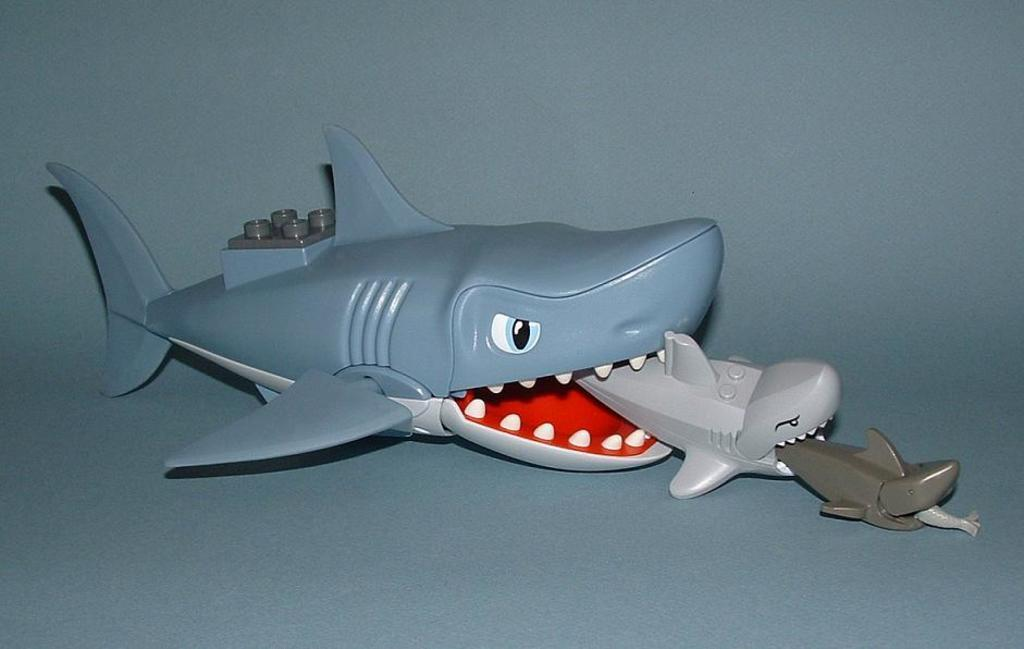What type of toys are present in the image? There are toys of sharks in the image. What scientific experiment is being conducted with the shark toys in the image? There is no scientific experiment being conducted with the shark toys in the image; the image only shows toys of sharks. 